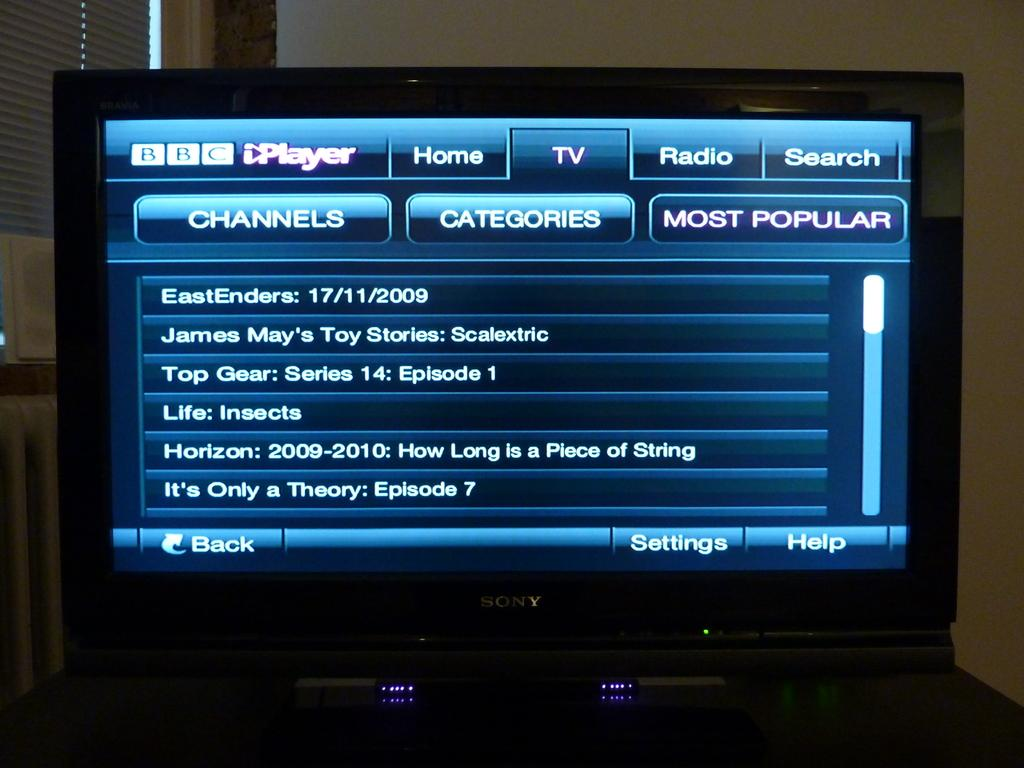<image>
Write a terse but informative summary of the picture. BBC channel is on top right corner of the screen 